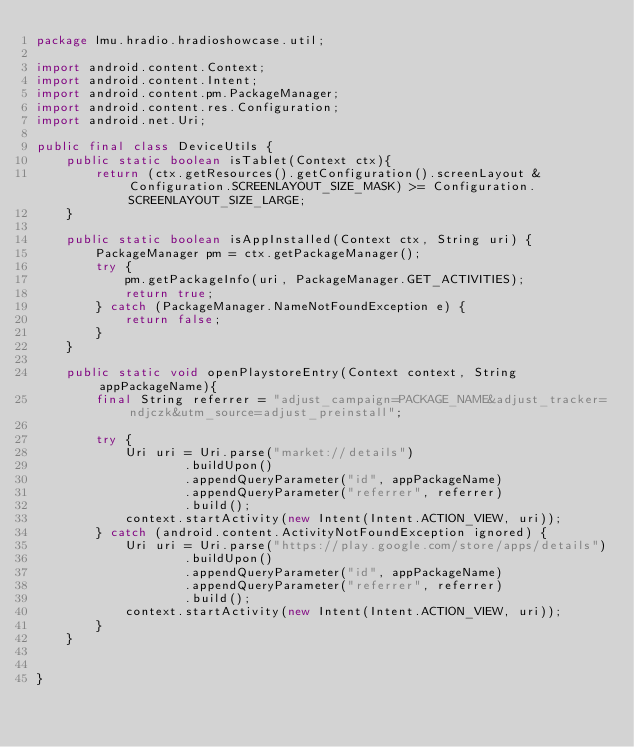<code> <loc_0><loc_0><loc_500><loc_500><_Java_>package lmu.hradio.hradioshowcase.util;

import android.content.Context;
import android.content.Intent;
import android.content.pm.PackageManager;
import android.content.res.Configuration;
import android.net.Uri;

public final class DeviceUtils {
    public static boolean isTablet(Context ctx){
        return (ctx.getResources().getConfiguration().screenLayout & Configuration.SCREENLAYOUT_SIZE_MASK) >= Configuration.SCREENLAYOUT_SIZE_LARGE;
    }

    public static boolean isAppInstalled(Context ctx, String uri) {
        PackageManager pm = ctx.getPackageManager();
        try {
            pm.getPackageInfo(uri, PackageManager.GET_ACTIVITIES);
            return true;
        } catch (PackageManager.NameNotFoundException e) {
            return false;
        }
    }

    public static void openPlaystoreEntry(Context context, String appPackageName){
        final String referrer = "adjust_campaign=PACKAGE_NAME&adjust_tracker=ndjczk&utm_source=adjust_preinstall";

        try {
            Uri uri = Uri.parse("market://details")
                    .buildUpon()
                    .appendQueryParameter("id", appPackageName)
                    .appendQueryParameter("referrer", referrer)
                    .build();
            context.startActivity(new Intent(Intent.ACTION_VIEW, uri));
        } catch (android.content.ActivityNotFoundException ignored) {
            Uri uri = Uri.parse("https://play.google.com/store/apps/details")
                    .buildUpon()
                    .appendQueryParameter("id", appPackageName)
                    .appendQueryParameter("referrer", referrer)
                    .build();
            context.startActivity(new Intent(Intent.ACTION_VIEW, uri));
        }
    }


}
</code> 